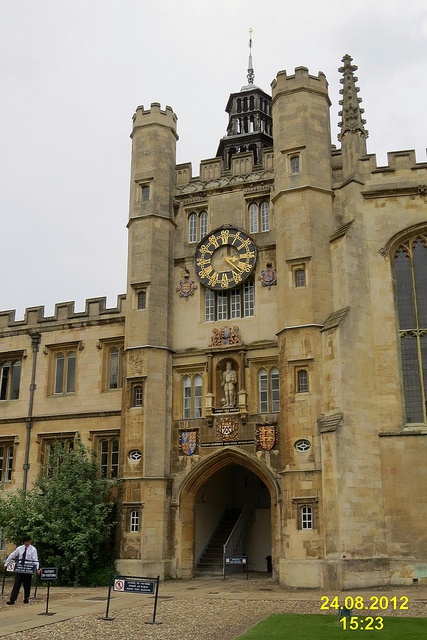Describe the objects in this image and their specific colors. I can see clock in lightgray, tan, gray, and black tones, people in lightgray, black, darkgray, and gray tones, and tie in lightgray, black, gray, and darkgray tones in this image. 